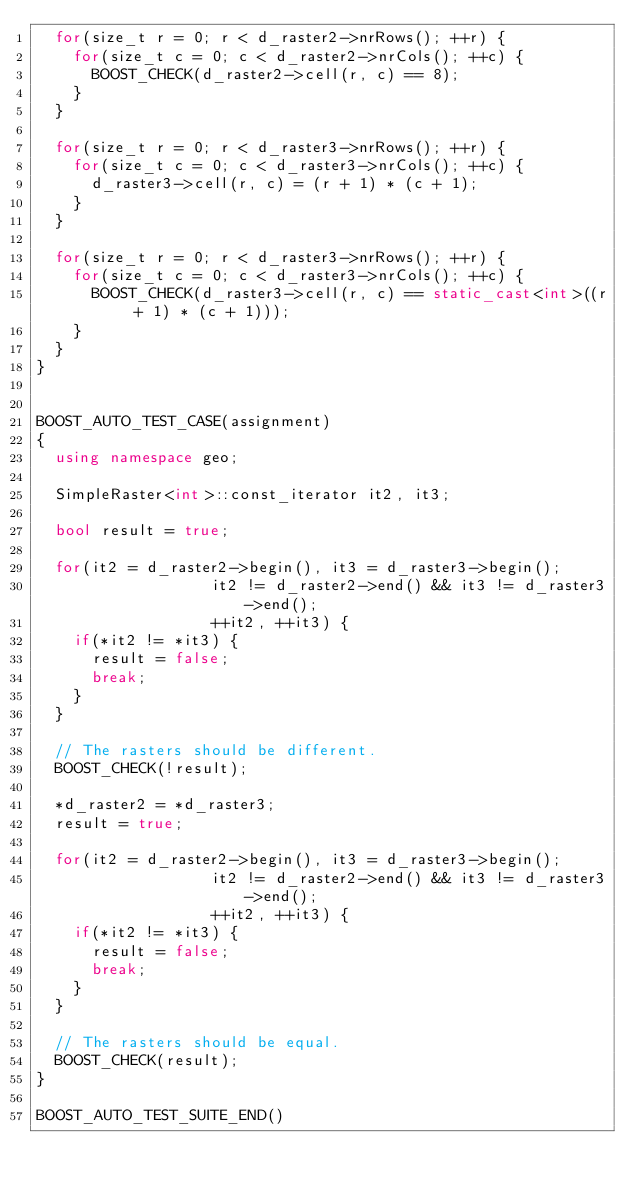<code> <loc_0><loc_0><loc_500><loc_500><_C++_>  for(size_t r = 0; r < d_raster2->nrRows(); ++r) {
    for(size_t c = 0; c < d_raster2->nrCols(); ++c) {
      BOOST_CHECK(d_raster2->cell(r, c) == 8);
    }
  }

  for(size_t r = 0; r < d_raster3->nrRows(); ++r) {
    for(size_t c = 0; c < d_raster3->nrCols(); ++c) {
      d_raster3->cell(r, c) = (r + 1) * (c + 1);
    }
  }

  for(size_t r = 0; r < d_raster3->nrRows(); ++r) {
    for(size_t c = 0; c < d_raster3->nrCols(); ++c) {
      BOOST_CHECK(d_raster3->cell(r, c) == static_cast<int>((r + 1) * (c + 1)));
    }
  }
}


BOOST_AUTO_TEST_CASE(assignment)
{
  using namespace geo;

  SimpleRaster<int>::const_iterator it2, it3;

  bool result = true;

  for(it2 = d_raster2->begin(), it3 = d_raster3->begin();
                   it2 != d_raster2->end() && it3 != d_raster3->end();
                   ++it2, ++it3) {
    if(*it2 != *it3) {
      result = false;
      break;
    }
  }

  // The rasters should be different.
  BOOST_CHECK(!result);

  *d_raster2 = *d_raster3;
  result = true;

  for(it2 = d_raster2->begin(), it3 = d_raster3->begin();
                   it2 != d_raster2->end() && it3 != d_raster3->end();
                   ++it2, ++it3) {
    if(*it2 != *it3) {
      result = false;
      break;
    }
  }

  // The rasters should be equal.
  BOOST_CHECK(result);
}

BOOST_AUTO_TEST_SUITE_END()
</code> 